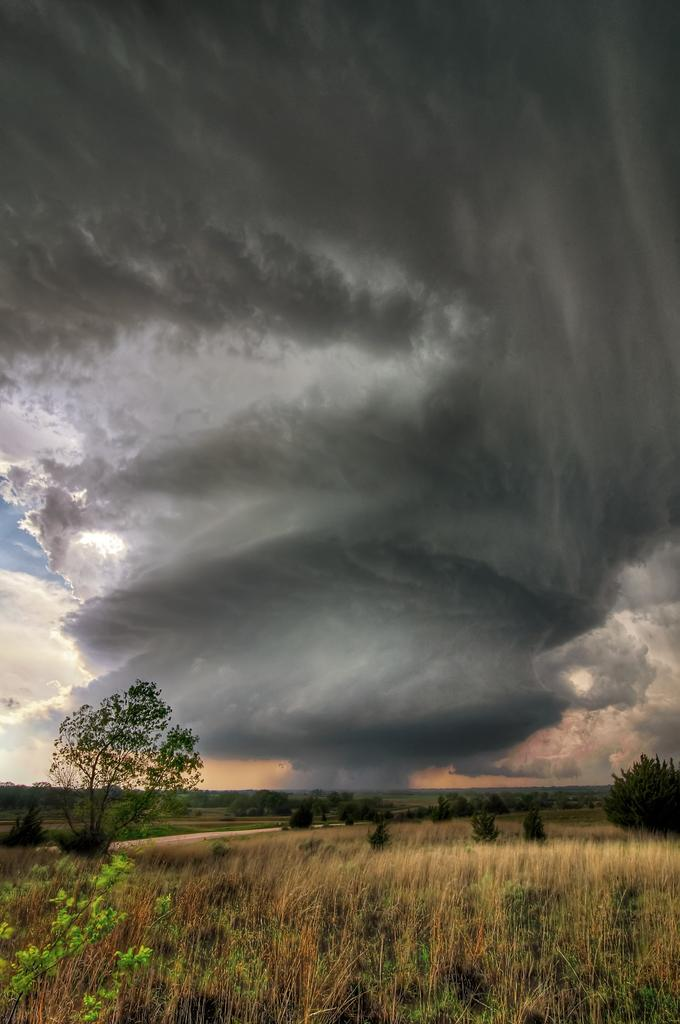What type of vegetation can be seen in the foreground of the image? There is grass in the foreground of the image. What type of vegetation can be seen in the background of the image? There are trees in the background of the image. What is visible in the sky in the image? The sky is visible in the image. What can be observed in the sky in the image? Clouds are present in the sky. What type of health advice can be seen written on the grass in the image? There is no health advice written on the grass in the image; it is a natural landscape with grass, trees, and sky. What is the elbow's role in the image? There is no elbow present in the image, as it is a natural landscape with grass, trees, and sky. 